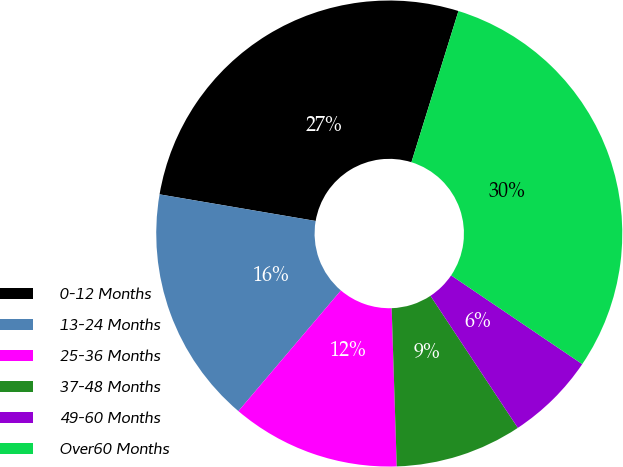<chart> <loc_0><loc_0><loc_500><loc_500><pie_chart><fcel>0-12 Months<fcel>13-24 Months<fcel>25-36 Months<fcel>37-48 Months<fcel>49-60 Months<fcel>Over60 Months<nl><fcel>27.11%<fcel>16.48%<fcel>11.72%<fcel>8.79%<fcel>6.23%<fcel>29.67%<nl></chart> 